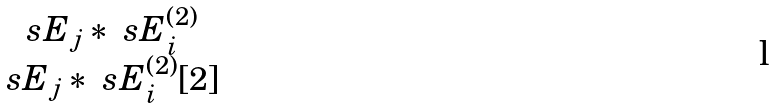<formula> <loc_0><loc_0><loc_500><loc_500>\begin{matrix} \ s E _ { j } * \ s E _ { i } ^ { ( 2 ) } \\ \ s E _ { j } * \ s E _ { i } ^ { ( 2 ) } [ 2 ] \end{matrix}</formula> 